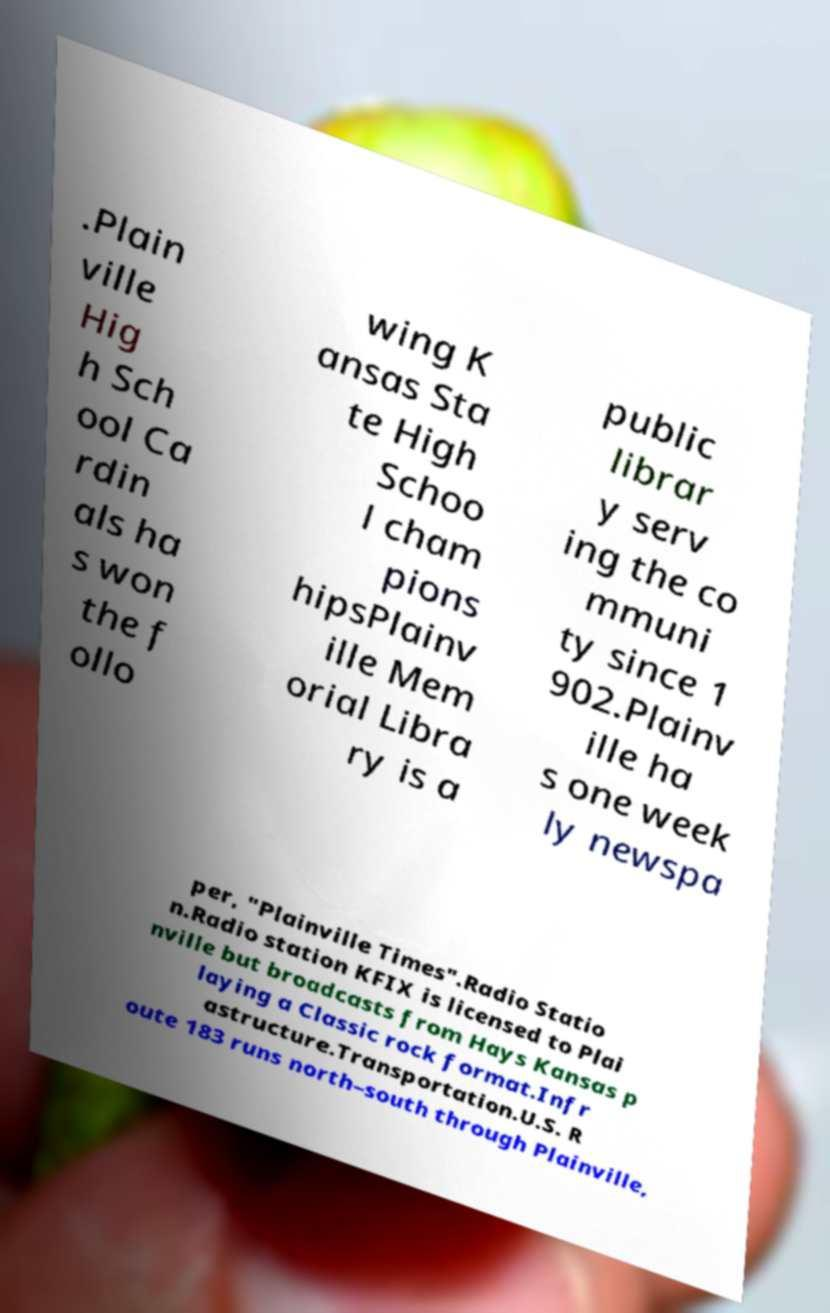Could you extract and type out the text from this image? .Plain ville Hig h Sch ool Ca rdin als ha s won the f ollo wing K ansas Sta te High Schoo l cham pions hipsPlainv ille Mem orial Libra ry is a public librar y serv ing the co mmuni ty since 1 902.Plainv ille ha s one week ly newspa per, "Plainville Times".Radio Statio n.Radio station KFIX is licensed to Plai nville but broadcasts from Hays Kansas p laying a Classic rock format.Infr astructure.Transportation.U.S. R oute 183 runs north–south through Plainville, 